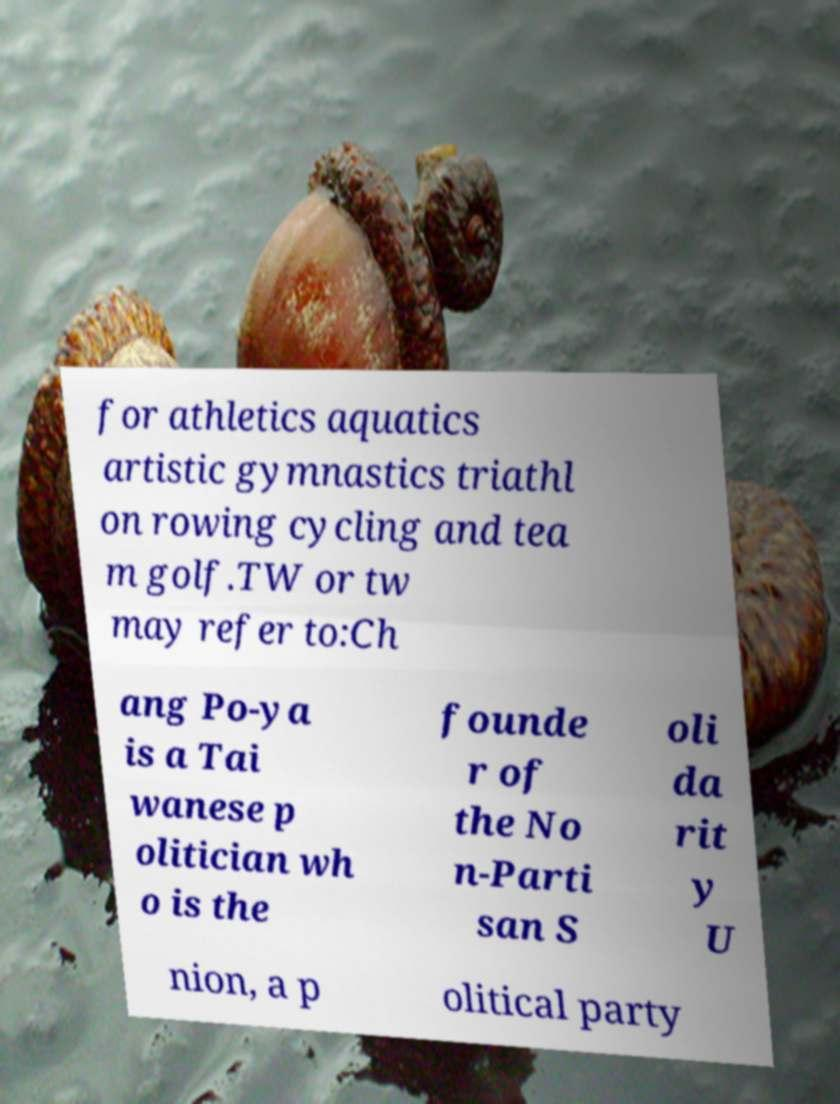Could you extract and type out the text from this image? for athletics aquatics artistic gymnastics triathl on rowing cycling and tea m golf.TW or tw may refer to:Ch ang Po-ya is a Tai wanese p olitician wh o is the founde r of the No n-Parti san S oli da rit y U nion, a p olitical party 